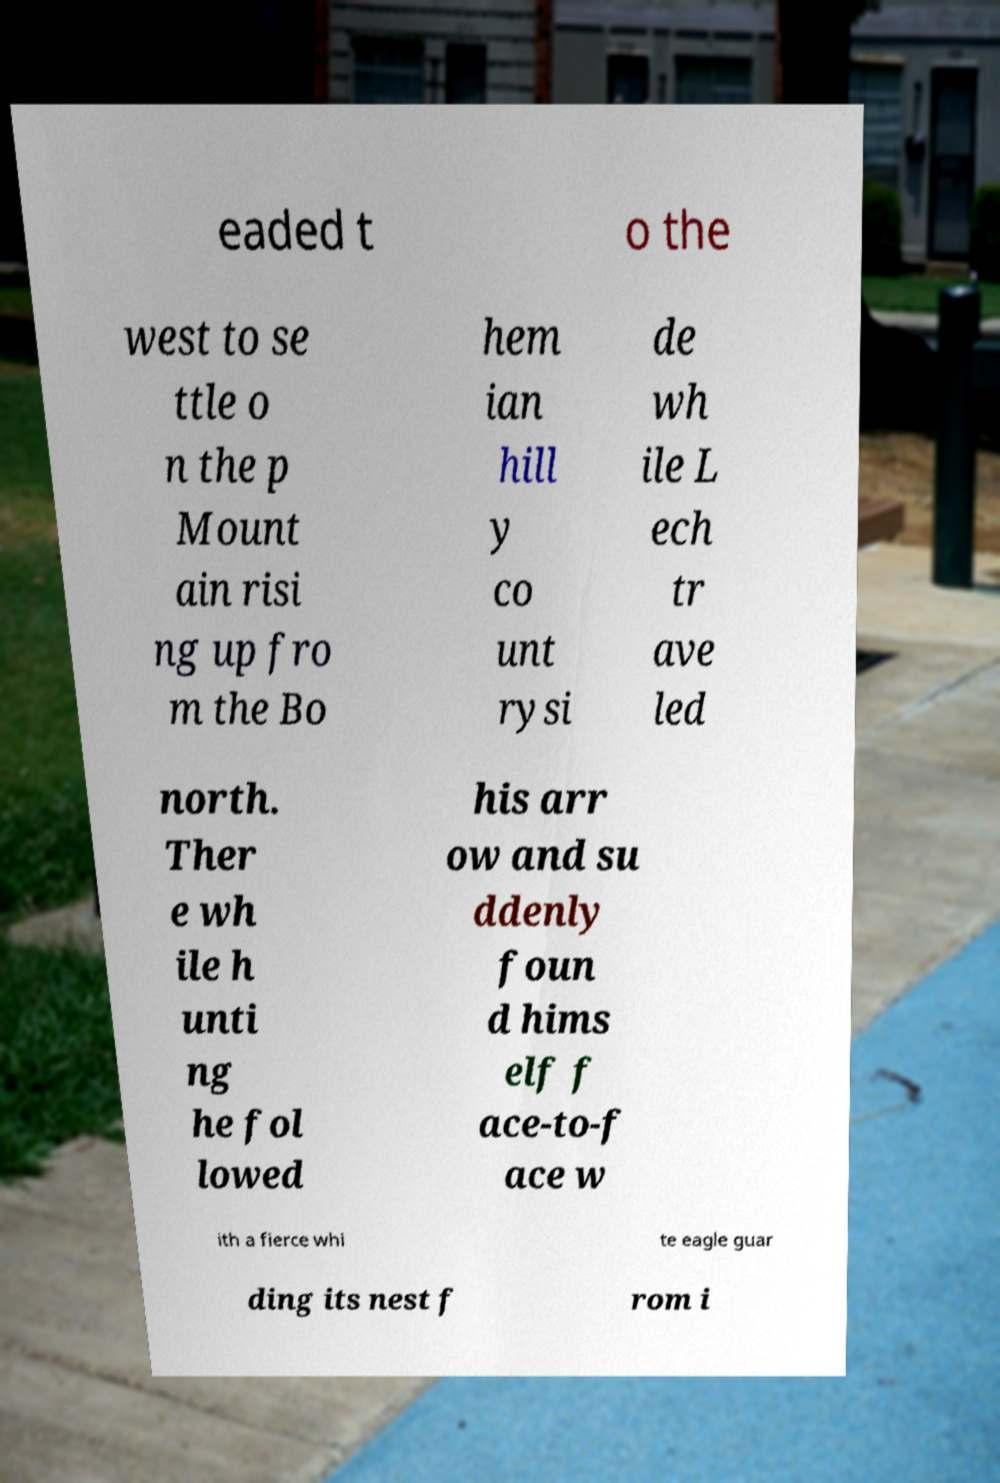What messages or text are displayed in this image? I need them in a readable, typed format. eaded t o the west to se ttle o n the p Mount ain risi ng up fro m the Bo hem ian hill y co unt rysi de wh ile L ech tr ave led north. Ther e wh ile h unti ng he fol lowed his arr ow and su ddenly foun d hims elf f ace-to-f ace w ith a fierce whi te eagle guar ding its nest f rom i 